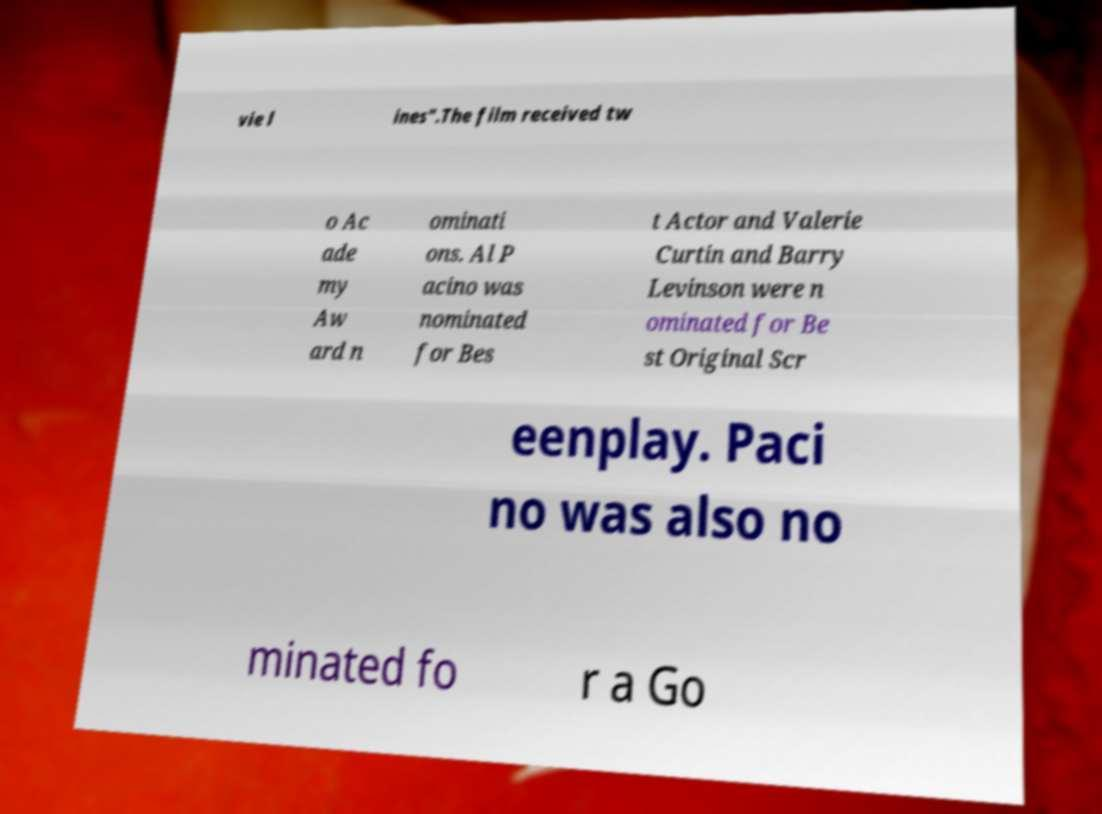Please identify and transcribe the text found in this image. vie l ines".The film received tw o Ac ade my Aw ard n ominati ons. Al P acino was nominated for Bes t Actor and Valerie Curtin and Barry Levinson were n ominated for Be st Original Scr eenplay. Paci no was also no minated fo r a Go 